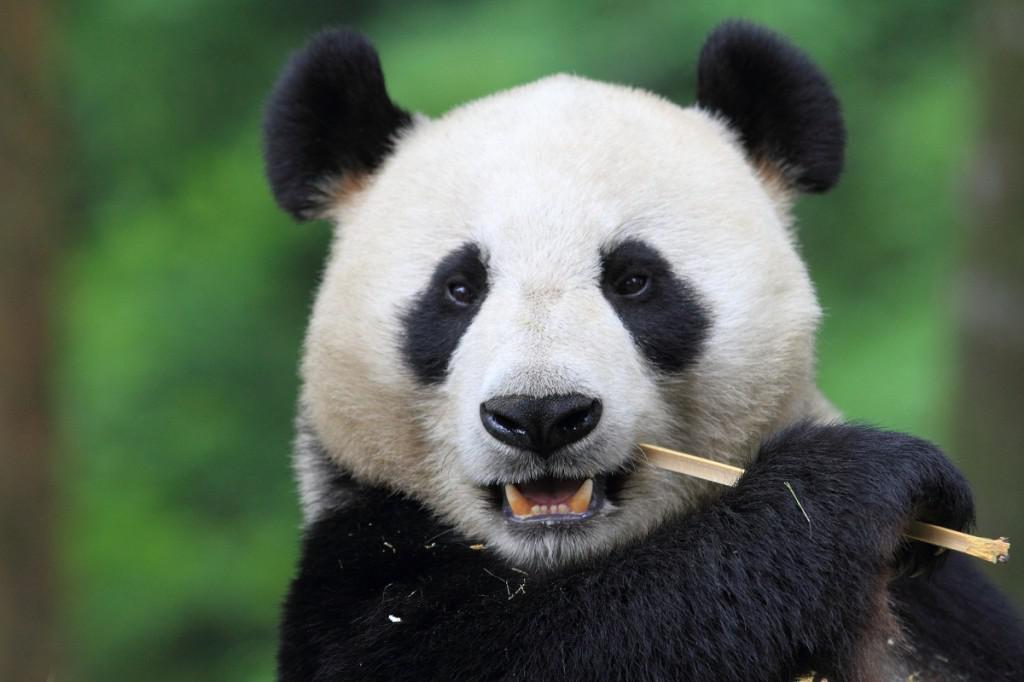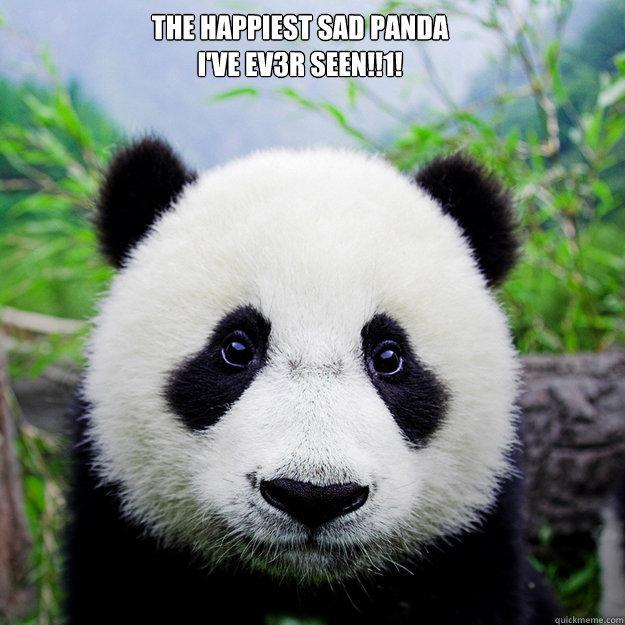The first image is the image on the left, the second image is the image on the right. Considering the images on both sides, is "The left and right image contains the same number of pandas." valid? Answer yes or no. Yes. 